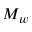<formula> <loc_0><loc_0><loc_500><loc_500>M _ { w }</formula> 